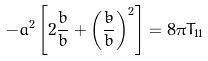Convert formula to latex. <formula><loc_0><loc_0><loc_500><loc_500>- a ^ { 2 } \left [ 2 \frac { \ddot { b } } { b } + \left ( \frac { \dot { b } } { b } \right ) ^ { 2 } \right ] = 8 \pi T _ { 1 1 }</formula> 